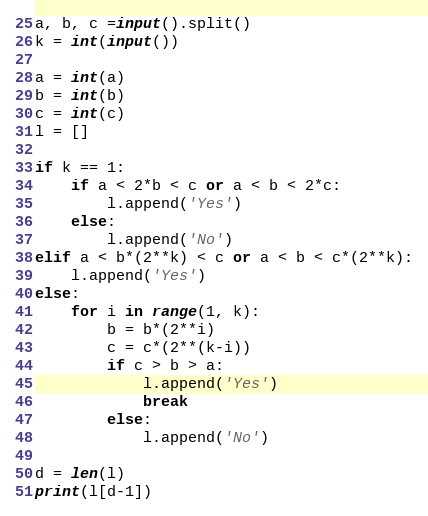<code> <loc_0><loc_0><loc_500><loc_500><_Python_>a, b, c =input().split()
k = int(input())

a = int(a)
b = int(b)
c = int(c)
l = []

if k == 1:
    if a < 2*b < c or a < b < 2*c:
        l.append('Yes')
    else:
        l.append('No')
elif a < b*(2**k) < c or a < b < c*(2**k):
    l.append('Yes')
else:
    for i in range(1, k):
        b = b*(2**i)
        c = c*(2**(k-i))
        if c > b > a:
            l.append('Yes')
            break
        else:
            l.append('No')

d = len(l)
print(l[d-1])</code> 